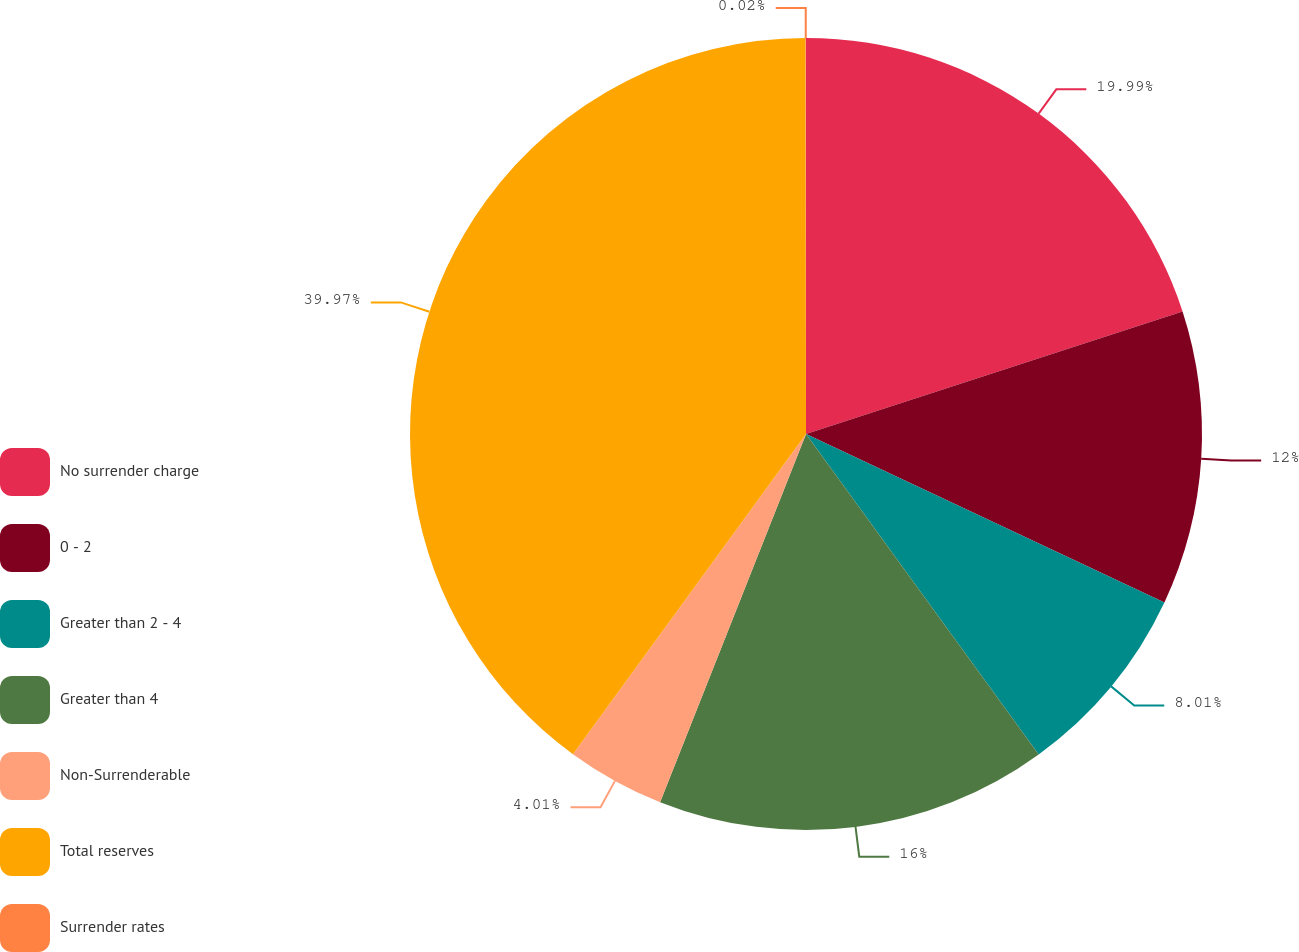Convert chart to OTSL. <chart><loc_0><loc_0><loc_500><loc_500><pie_chart><fcel>No surrender charge<fcel>0 - 2<fcel>Greater than 2 - 4<fcel>Greater than 4<fcel>Non-Surrenderable<fcel>Total reserves<fcel>Surrender rates<nl><fcel>19.99%<fcel>12.0%<fcel>8.01%<fcel>16.0%<fcel>4.01%<fcel>39.96%<fcel>0.02%<nl></chart> 